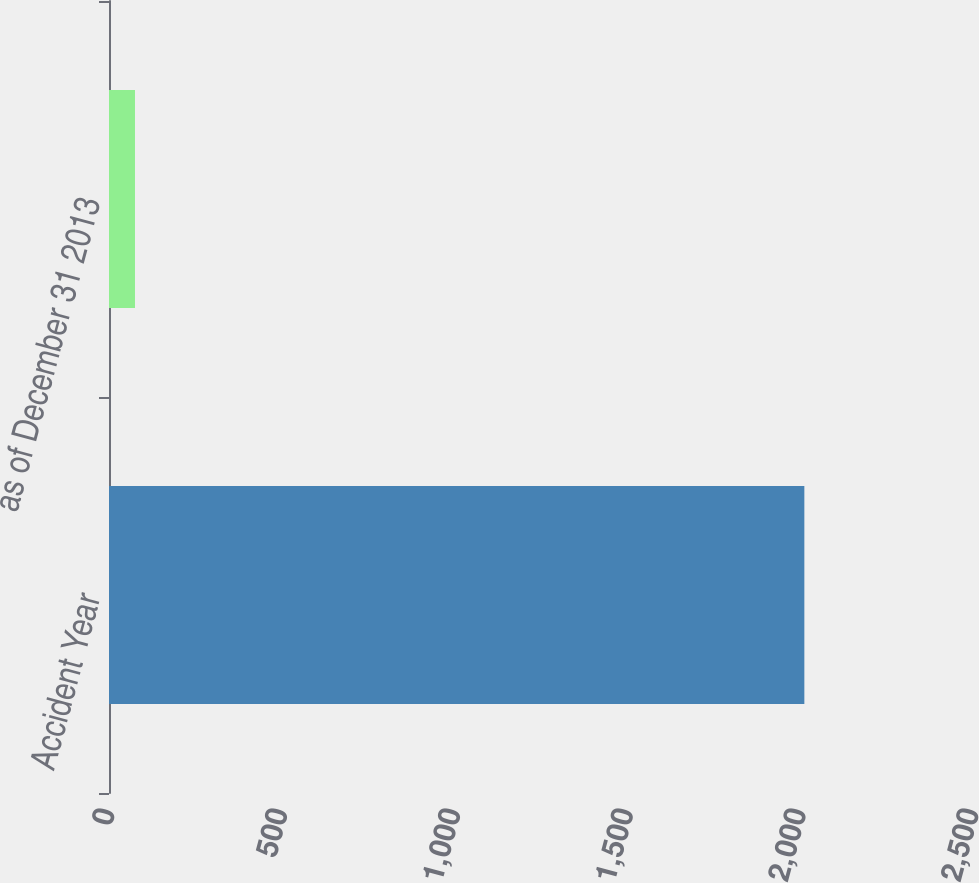<chart> <loc_0><loc_0><loc_500><loc_500><bar_chart><fcel>Accident Year<fcel>as of December 31 2013<nl><fcel>2012<fcel>75.2<nl></chart> 